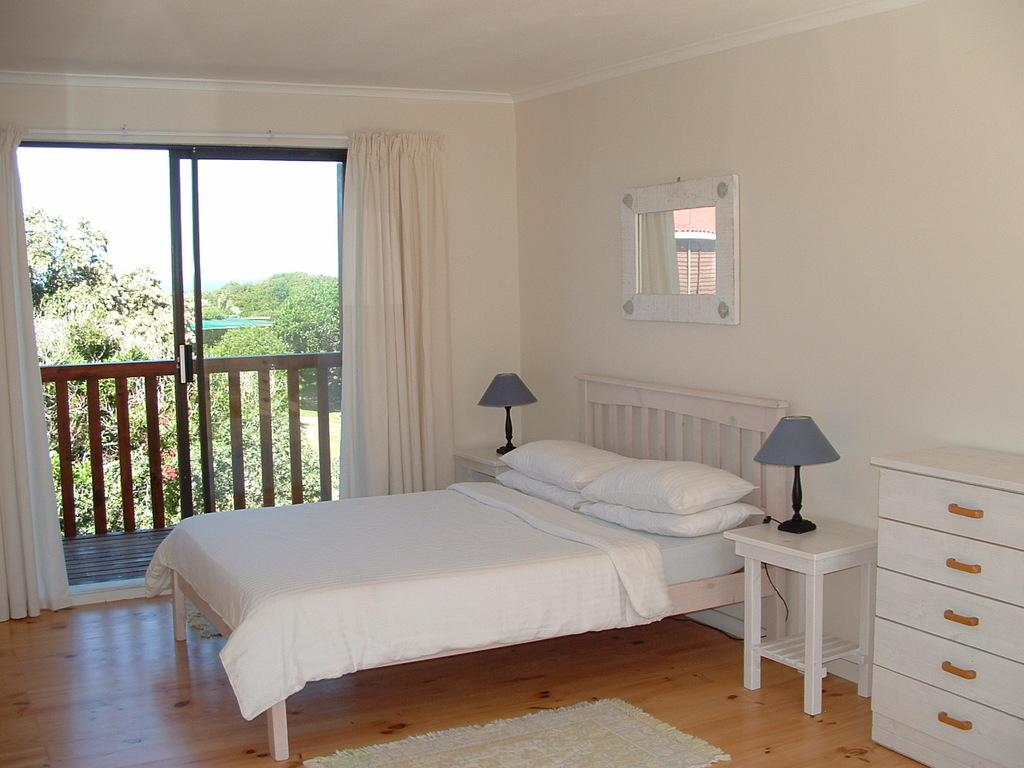What type of room is depicted in the image? The image is of a bedroom. What is the main piece of furniture in the bedroom? There is a bed in the bedroom. What other storage or organizational features are present in the bedroom? There are cupboards in the bedroom. What is used for illumination in the bedroom? There are lights in the bedroom. What is used for personal grooming in the bedroom? There is a mirror in the bedroom. What type of window treatment is present in the bedroom? There is a curtain in the bedroom. What can be seen outside the bedroom? Trees are visible from the bedroom, and the sky is visible at the top of the image. How many pizzas are on the bed in the image? There are no pizzas present in the image; it is a bedroom with a bed, cupboards, lights, mirror, and curtain. 